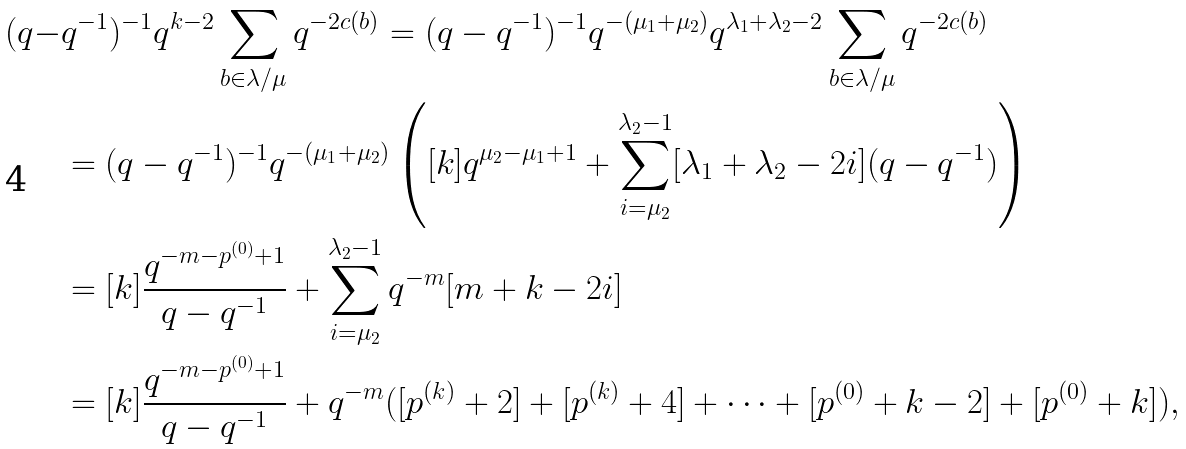Convert formula to latex. <formula><loc_0><loc_0><loc_500><loc_500>( q - & q ^ { - 1 } ) ^ { - 1 } q ^ { k - 2 } \sum _ { b \in \lambda / \mu } q ^ { - 2 c ( b ) } = ( q - q ^ { - 1 } ) ^ { - 1 } q ^ { - ( \mu _ { 1 } + \mu _ { 2 } ) } q ^ { \lambda _ { 1 } + \lambda _ { 2 } - 2 } \sum _ { b \in \lambda / \mu } q ^ { - 2 c ( b ) } \\ & = ( q - q ^ { - 1 } ) ^ { - 1 } q ^ { - ( \mu _ { 1 } + \mu _ { 2 } ) } \left ( [ k ] q ^ { \mu _ { 2 } - \mu _ { 1 } + 1 } + \sum _ { i = \mu _ { 2 } } ^ { \lambda _ { 2 } - 1 } [ \lambda _ { 1 } + \lambda _ { 2 } - 2 i ] ( q - q ^ { - 1 } ) \right ) \\ & = [ k ] \frac { q ^ { - m - p ^ { ( 0 ) } + 1 } } { q - q ^ { - 1 } } + \sum _ { i = \mu _ { 2 } } ^ { \lambda _ { 2 } - 1 } q ^ { - m } [ m + k - 2 i ] \\ & = [ k ] \frac { q ^ { - m - p ^ { ( 0 ) } + 1 } } { q - q ^ { - 1 } } + q ^ { - m } ( [ p ^ { ( k ) } + 2 ] + [ p ^ { ( k ) } + 4 ] + \cdots + [ p ^ { ( 0 ) } + k - 2 ] + [ p ^ { ( 0 ) } + k ] ) ,</formula> 